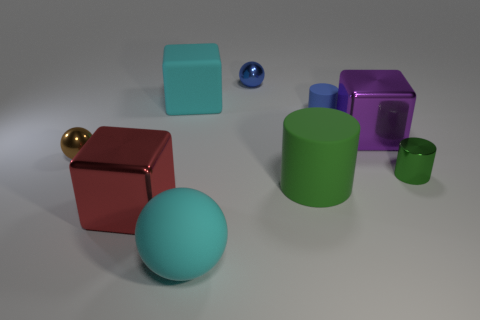Subtract all blue cylinders. How many cylinders are left? 2 Subtract all cyan spheres. How many green cylinders are left? 2 Add 1 large cyan metal cylinders. How many objects exist? 10 Subtract 1 cubes. How many cubes are left? 2 Subtract all yellow cubes. Subtract all green spheres. How many cubes are left? 3 Subtract 1 blue spheres. How many objects are left? 8 Subtract all spheres. How many objects are left? 6 Subtract all matte spheres. Subtract all tiny green matte cylinders. How many objects are left? 8 Add 5 blue cylinders. How many blue cylinders are left? 6 Add 2 rubber cylinders. How many rubber cylinders exist? 4 